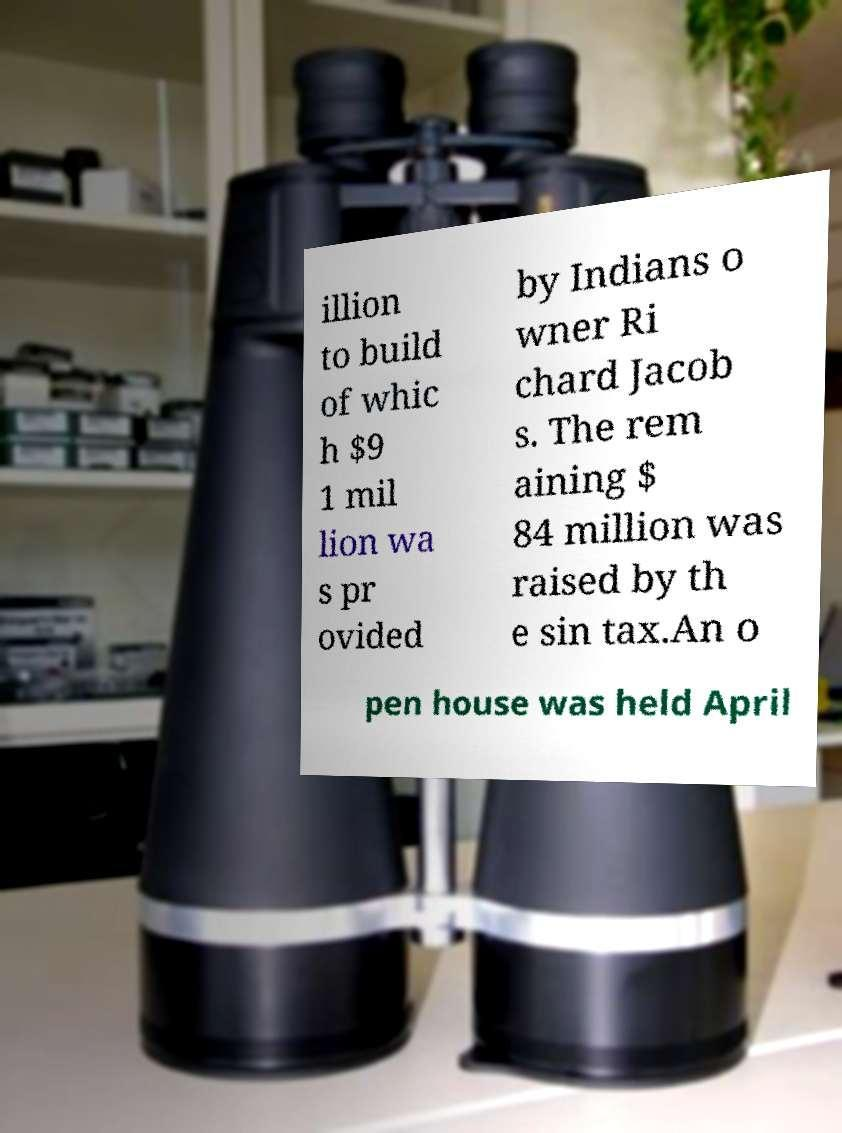There's text embedded in this image that I need extracted. Can you transcribe it verbatim? illion to build of whic h $9 1 mil lion wa s pr ovided by Indians o wner Ri chard Jacob s. The rem aining $ 84 million was raised by th e sin tax.An o pen house was held April 